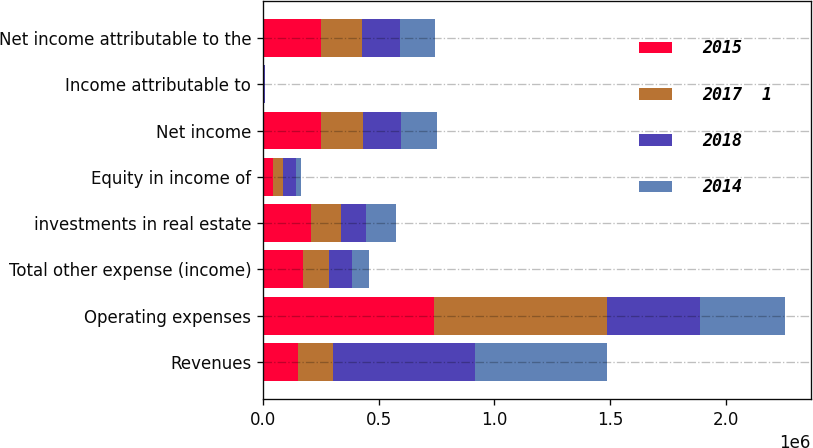Convert chart. <chart><loc_0><loc_0><loc_500><loc_500><stacked_bar_chart><ecel><fcel>Revenues<fcel>Operating expenses<fcel>Total other expense (income)<fcel>investments in real estate<fcel>Equity in income of<fcel>Net income<fcel>Income attributable to<fcel>Net income attributable to the<nl><fcel>2015<fcel>151420<fcel>740806<fcel>170818<fcel>209351<fcel>42974<fcel>252325<fcel>2673<fcel>249652<nl><fcel>2017  1<fcel>151420<fcel>744763<fcel>113661<fcel>125902<fcel>43341<fcel>178980<fcel>2515<fcel>176465<nl><fcel>2018<fcel>614371<fcel>403152<fcel>100745<fcel>110474<fcel>56518<fcel>166992<fcel>1813<fcel>165179<nl><fcel>2014<fcel>569763<fcel>365098<fcel>74630<fcel>130035<fcel>22508<fcel>152543<fcel>2247<fcel>150296<nl></chart> 